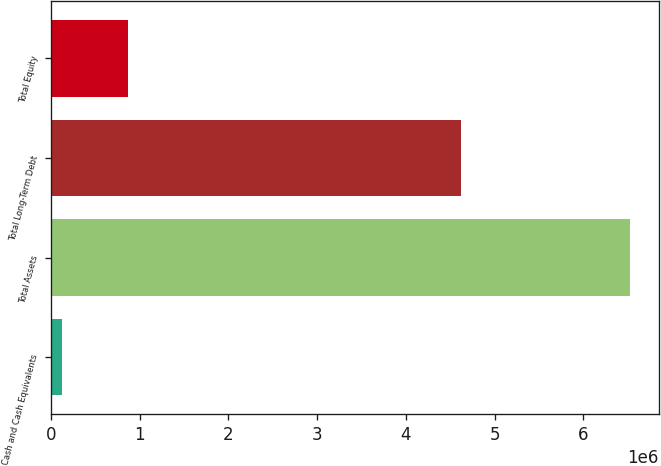Convert chart to OTSL. <chart><loc_0><loc_0><loc_500><loc_500><bar_chart><fcel>Cash and Cash Equivalents<fcel>Total Assets<fcel>Total Long-Term Debt<fcel>Total Equity<nl><fcel>125933<fcel>6.52326e+06<fcel>4.61645e+06<fcel>869955<nl></chart> 